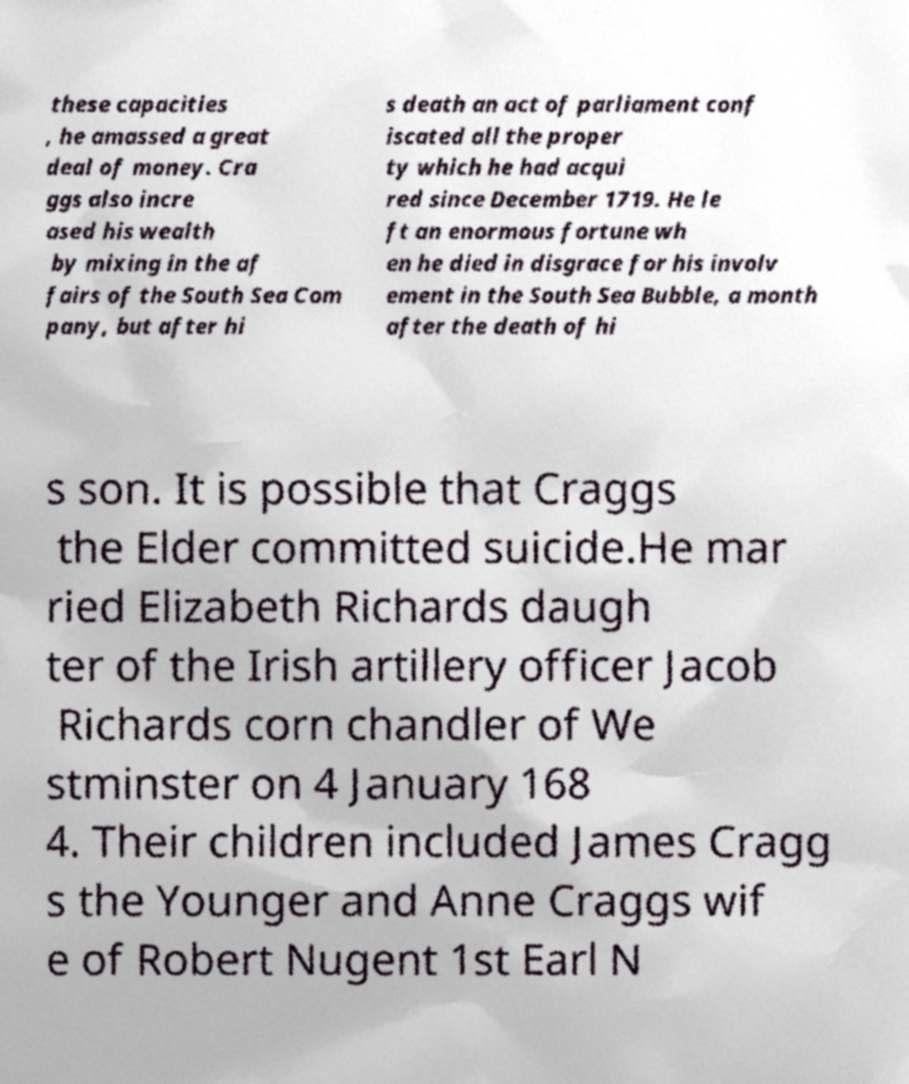Could you assist in decoding the text presented in this image and type it out clearly? these capacities , he amassed a great deal of money. Cra ggs also incre ased his wealth by mixing in the af fairs of the South Sea Com pany, but after hi s death an act of parliament conf iscated all the proper ty which he had acqui red since December 1719. He le ft an enormous fortune wh en he died in disgrace for his involv ement in the South Sea Bubble, a month after the death of hi s son. It is possible that Craggs the Elder committed suicide.He mar ried Elizabeth Richards daugh ter of the Irish artillery officer Jacob Richards corn chandler of We stminster on 4 January 168 4. Their children included James Cragg s the Younger and Anne Craggs wif e of Robert Nugent 1st Earl N 